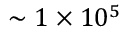Convert formula to latex. <formula><loc_0><loc_0><loc_500><loc_500>\sim 1 \times 1 0 ^ { 5 }</formula> 